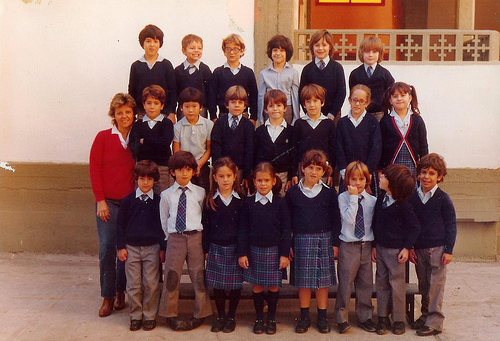<image>Which jacket is different? It is unknown which jacket is different. It could be the teacher's jacket or the red one. Which jacket is different? I am not sure which jacket is different. It can be any of the red jackets mentioned. 